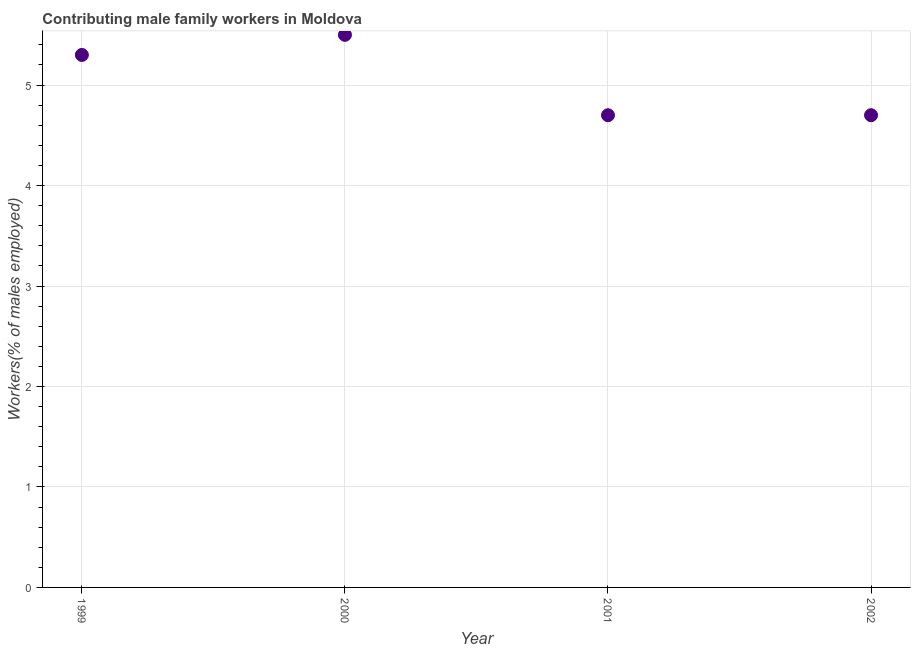What is the contributing male family workers in 1999?
Provide a succinct answer. 5.3. Across all years, what is the minimum contributing male family workers?
Your answer should be very brief. 4.7. What is the sum of the contributing male family workers?
Give a very brief answer. 20.2. What is the difference between the contributing male family workers in 1999 and 2000?
Provide a short and direct response. -0.2. What is the average contributing male family workers per year?
Ensure brevity in your answer.  5.05. What is the median contributing male family workers?
Offer a terse response. 5. What is the ratio of the contributing male family workers in 2000 to that in 2001?
Provide a succinct answer. 1.17. Is the contributing male family workers in 2001 less than that in 2002?
Provide a short and direct response. No. Is the difference between the contributing male family workers in 2000 and 2002 greater than the difference between any two years?
Offer a terse response. Yes. What is the difference between the highest and the second highest contributing male family workers?
Keep it short and to the point. 0.2. Is the sum of the contributing male family workers in 1999 and 2002 greater than the maximum contributing male family workers across all years?
Give a very brief answer. Yes. What is the difference between the highest and the lowest contributing male family workers?
Ensure brevity in your answer.  0.8. In how many years, is the contributing male family workers greater than the average contributing male family workers taken over all years?
Your answer should be compact. 2. What is the difference between two consecutive major ticks on the Y-axis?
Your response must be concise. 1. Are the values on the major ticks of Y-axis written in scientific E-notation?
Give a very brief answer. No. Does the graph contain any zero values?
Give a very brief answer. No. Does the graph contain grids?
Your answer should be compact. Yes. What is the title of the graph?
Ensure brevity in your answer.  Contributing male family workers in Moldova. What is the label or title of the Y-axis?
Offer a terse response. Workers(% of males employed). What is the Workers(% of males employed) in 1999?
Provide a succinct answer. 5.3. What is the Workers(% of males employed) in 2001?
Make the answer very short. 4.7. What is the Workers(% of males employed) in 2002?
Offer a terse response. 4.7. What is the ratio of the Workers(% of males employed) in 1999 to that in 2001?
Your response must be concise. 1.13. What is the ratio of the Workers(% of males employed) in 1999 to that in 2002?
Offer a very short reply. 1.13. What is the ratio of the Workers(% of males employed) in 2000 to that in 2001?
Your response must be concise. 1.17. What is the ratio of the Workers(% of males employed) in 2000 to that in 2002?
Make the answer very short. 1.17. 